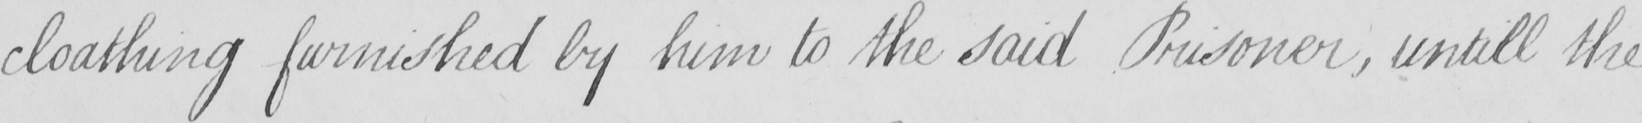Can you tell me what this handwritten text says? cloathing furnished by him to the said Prisoner , untill the 